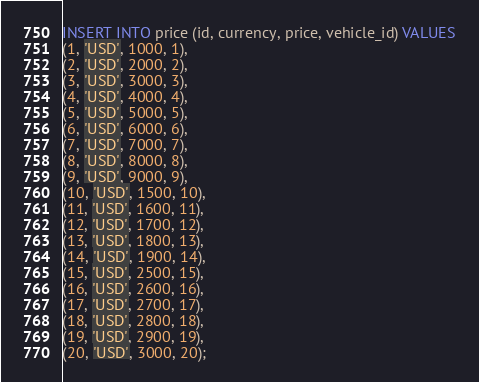Convert code to text. <code><loc_0><loc_0><loc_500><loc_500><_SQL_>INSERT INTO price (id, currency, price, vehicle_id) VALUES
(1, 'USD', 1000, 1),
(2, 'USD', 2000, 2),
(3, 'USD', 3000, 3),
(4, 'USD', 4000, 4),
(5, 'USD', 5000, 5),
(6, 'USD', 6000, 6),
(7, 'USD', 7000, 7),
(8, 'USD', 8000, 8),
(9, 'USD', 9000, 9),
(10, 'USD', 1500, 10),
(11, 'USD', 1600, 11),
(12, 'USD', 1700, 12),
(13, 'USD', 1800, 13),
(14, 'USD', 1900, 14),
(15, 'USD', 2500, 15),
(16, 'USD', 2600, 16),
(17, 'USD', 2700, 17),
(18, 'USD', 2800, 18),
(19, 'USD', 2900, 19),
(20, 'USD', 3000, 20);</code> 